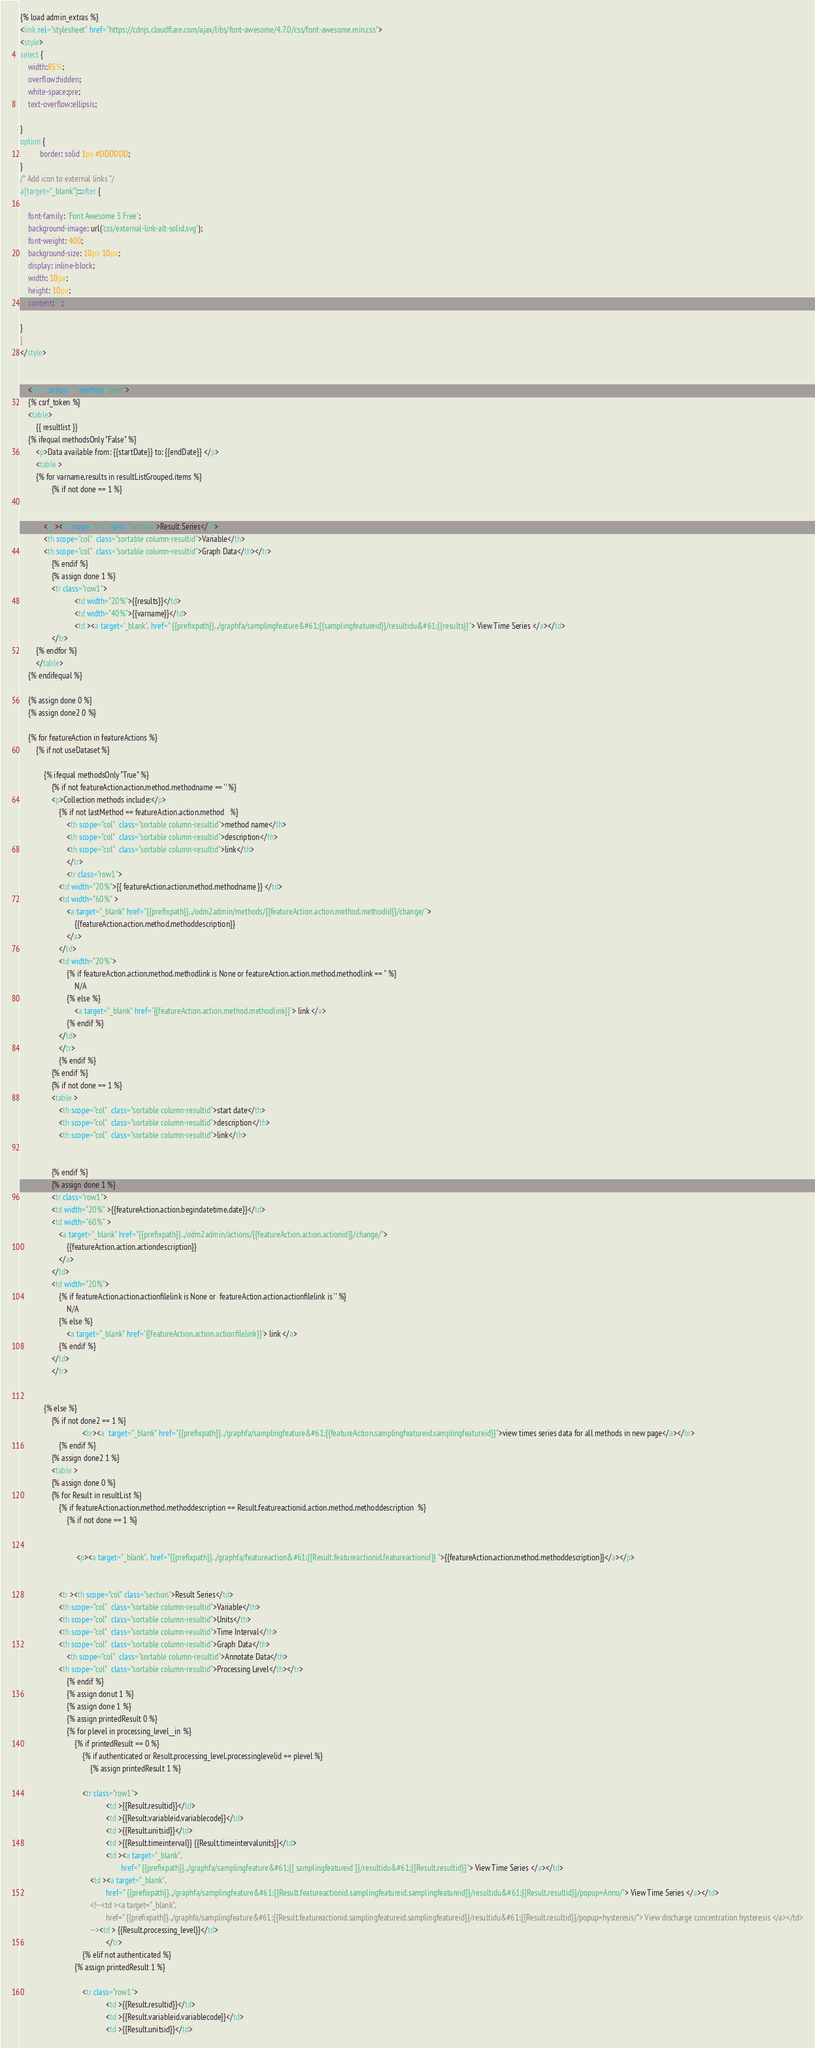<code> <loc_0><loc_0><loc_500><loc_500><_HTML_>
{% load admin_extras %}
<link rel="stylesheet" href="https://cdnjs.cloudflare.com/ajax/libs/font-awesome/4.7.0/css/font-awesome.min.css">
<style>
select {
    width:85%; 
    overflow:hidden; 
    white-space:pre; 
    text-overflow:ellipsis;
    
}
option {
          border: solid 1px #DDDDDD; 
}
/* Add icon to external links */
a[target="_blank"]::after {

    font-family: 'Font Awesome 5 Free';
    background-image: url('css/external-link-alt-solid.svg');
    font-weight: 400;
    background-size: 10px 10px;
    display: inline-block;
    width: 10px;
    height: 10px;
    content: "";

}
}
</style>

    
	<form action="" method="post">
	{% csrf_token %}
	<table>
		{{ resultlist }}
	{% ifequal methodsOnly "False" %}
		<p>Data available from: {{startDate}} to: {{endDate}} </p>
        <table >
        {% for varname,results in resultListGrouped.items %}
                {% if not done == 1 %}


            <tr ><th scope="col" class="section">Result Series</td>
            <th scope="col"  class="sortable column-resultid">Variable</th>
            <th scope="col"  class="sortable column-resultid">Graph Data</th></tr>
                {% endif %}
                {% assign done 1 %}
                <tr class="row1">
                            <td width="20%">{{results}}</td>
                            <td width="40%">{{varname}}</td>
                            <td ><a target='_blank', href=" {{prefixpath}}../graphfa/samplingfeature&#61;{{samplingfeatureid}}/resultidu&#61;{{results}}"> View Time Series </a></td>
                </tr>
        {% endfor %}
        </table>
	{% endifequal %}

	{% assign done 0 %}
	{% assign done2 0 %}

	{% for featureAction in featureActions %}
		{% if not useDataset %}

			{% ifequal methodsOnly "True" %}
				{% if not featureAction.action.method.methodname == '' %}
				<p>Collection methods include:</p>
					{% if not lastMethod == featureAction.action.method   %}
						<th scope="col"  class="sortable column-resultid">method name</th>
						<th scope="col"  class="sortable column-resultid">description</th>
						<th scope="col"  class="sortable column-resultid">link</th>
						</tr>
						<tr class="row1">
					<td width="20%">{{ featureAction.action.method.methodname }} </td>
					<td width="60%" >
						<a target="_blank" href="{{prefixpath}}../odm2admin/methods/{{featureAction.action.method.methodid}}/change/">
							{{featureAction.action.method.methoddescription}}
						</a>
					</td>
					<td width="20%">
						{% if featureAction.action.method.methodlink is None or featureAction.action.method.methodlink == '' %}
							N/A
						{% else %}
							<a target="_blank" href='{{featureAction.action.method.methodlink}}'> link </a>
						{% endif %}
					</td>
					</tr>
					{% endif %}
				{% endif %}
				{% if not done == 1 %}
				<table >
					<th scope="col"  class="sortable column-resultid">start date</th>
					<th scope="col"  class="sortable column-resultid">description</th>
					<th scope="col"  class="sortable column-resultid">link</th>

					
				{% endif %}
				{% assign done 1 %}
				<tr class="row1">
				<td width="20%" >{{featureAction.action.begindatetime.date}}</td>
                <td width="60%" >
                    <a target="_blank" href="{{prefixpath}}../odm2admin/actions/{{featureAction.action.actionid}}/change/">
                        {{featureAction.action.actiondescription}}
                    </a>
                </td>
				<td width="20%">
                    {% if featureAction.action.actionfilelink is None or  featureAction.action.actionfilelink is '' %}
                        N/A
                    {% else %}
                        <a target="_blank" href='{{featureAction.action.actionfilelink}}'> link </a>
                    {% endif %}
                </td>
                </tr>
				
			
			{% else %}
                {% if not done2 == 1 %}
                                <br><a  target="_blank" href="{{prefixpath}}../graphfa/samplingfeature&#61;{{featureAction.samplingfeatureid.samplingfeatureid}}">view times series data for all methods in new page</a></br>
					{% endif %}
                {% assign done2 1 %}
				<table >
                {% assign done 0 %}
				{% for Result in resultList %}
					{% if featureAction.action.method.methoddescription == Result.featureactionid.action.method.methoddescription  %}
						{% if not done == 1 %}


							 <p><a target="_blank", href="{{prefixpath}}../graphfa/featureaction&#61;{{Result.featureactionid.featureactionid}} ">{{featureAction.action.method.methoddescription}}</a></p>


					<tr ><th scope="col" class="section">Result Series</td>
					<th scope="col"  class="sortable column-resultid">Variable</th>
					<th scope="col"  class="sortable column-resultid">Units</th>
					<th scope="col"  class="sortable column-resultid">Time Interval</th>
					<th scope="col"  class="sortable column-resultid">Graph Data</th>
						<th scope="col"  class="sortable column-resultid">Annotate Data</th>
					<th scope="col"  class="sortable column-resultid">Processing Level</th></tr>
						{% endif %}
						{% assign donut 1 %}
						{% assign done 1 %}
						{% assign printedResult 0 %}
						{% for plevel in processing_level__in %}
							{% if printedResult == 0 %}
								{% if authenticated or Result.processing_level.processinglevelid == plevel %}
									{% assign printedResult 1 %}

								<tr class="row1">
											<td >{{Result.resultid}}</td>
											<td >{{Result.variableid.variablecode}}</td>
											<td >{{Result.unitsid}}</td>
											<td >{{Result.timeinterval}} {{Result.timeintervalunits}}</td>
											<td ><a target="_blank",
													href=" {{prefixpath}}../graphfa/samplingfeature&#61;{{ samplingfeatureid }}/resultidu&#61;{{Result.resultid}}"> View Time Series </a></td>
									<td ><a target="_blank",
											href=" {{prefixpath}}../graphfa/samplingfeature&#61;{{Result.featureactionid.samplingfeatureid.samplingfeatureid}}/resultidu&#61;{{Result.resultid}}/popup=Anno/"> View Time Series </a></td>
									<!--<td ><a target="_blank",
											href=" {{prefixpath}}../graphfa/samplingfeature&#61;{{Result.featureactionid.samplingfeatureid.samplingfeatureid}}/resultidu&#61;{{Result.resultid}}/popup=hysteresis/"> View discharge concentration hysteresis </a></td>
									--><td > {{Result.processing_level}}</td>
											</tr>
                                {% elif not authenticated %}
                    		{% assign printedResult 1 %}

								<tr class="row1">
											<td >{{Result.resultid}}</td>
											<td >{{Result.variableid.variablecode}}</td>
											<td >{{Result.unitsid}}</td></code> 